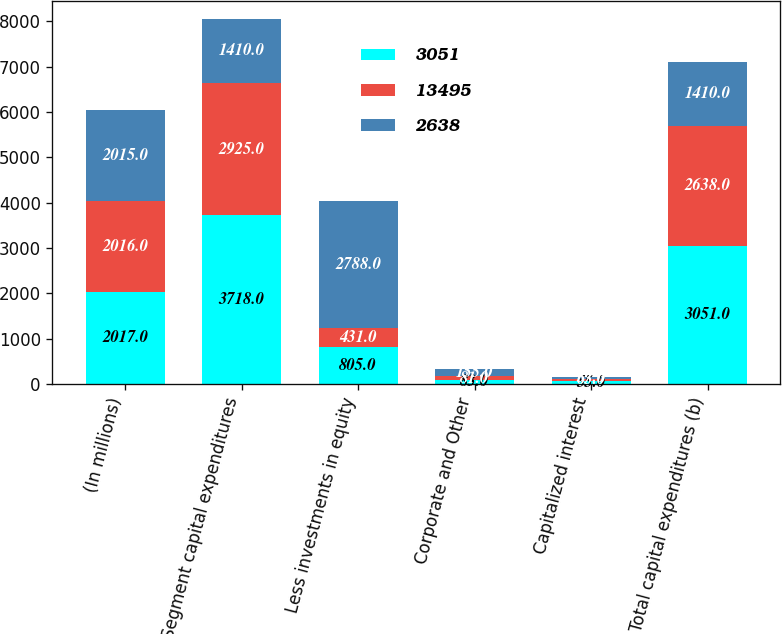Convert chart to OTSL. <chart><loc_0><loc_0><loc_500><loc_500><stacked_bar_chart><ecel><fcel>(In millions)<fcel>Segment capital expenditures<fcel>Less investments in equity<fcel>Corporate and Other<fcel>Capitalized interest<fcel>Total capital expenditures (b)<nl><fcel>3051<fcel>2017<fcel>3718<fcel>805<fcel>83<fcel>55<fcel>3051<nl><fcel>13495<fcel>2016<fcel>2925<fcel>431<fcel>81<fcel>63<fcel>2638<nl><fcel>2638<fcel>2015<fcel>1410<fcel>2788<fcel>155<fcel>37<fcel>1410<nl></chart> 